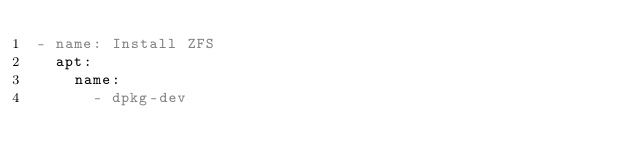Convert code to text. <code><loc_0><loc_0><loc_500><loc_500><_YAML_>- name: Install ZFS
  apt:
    name:
      - dpkg-dev</code> 